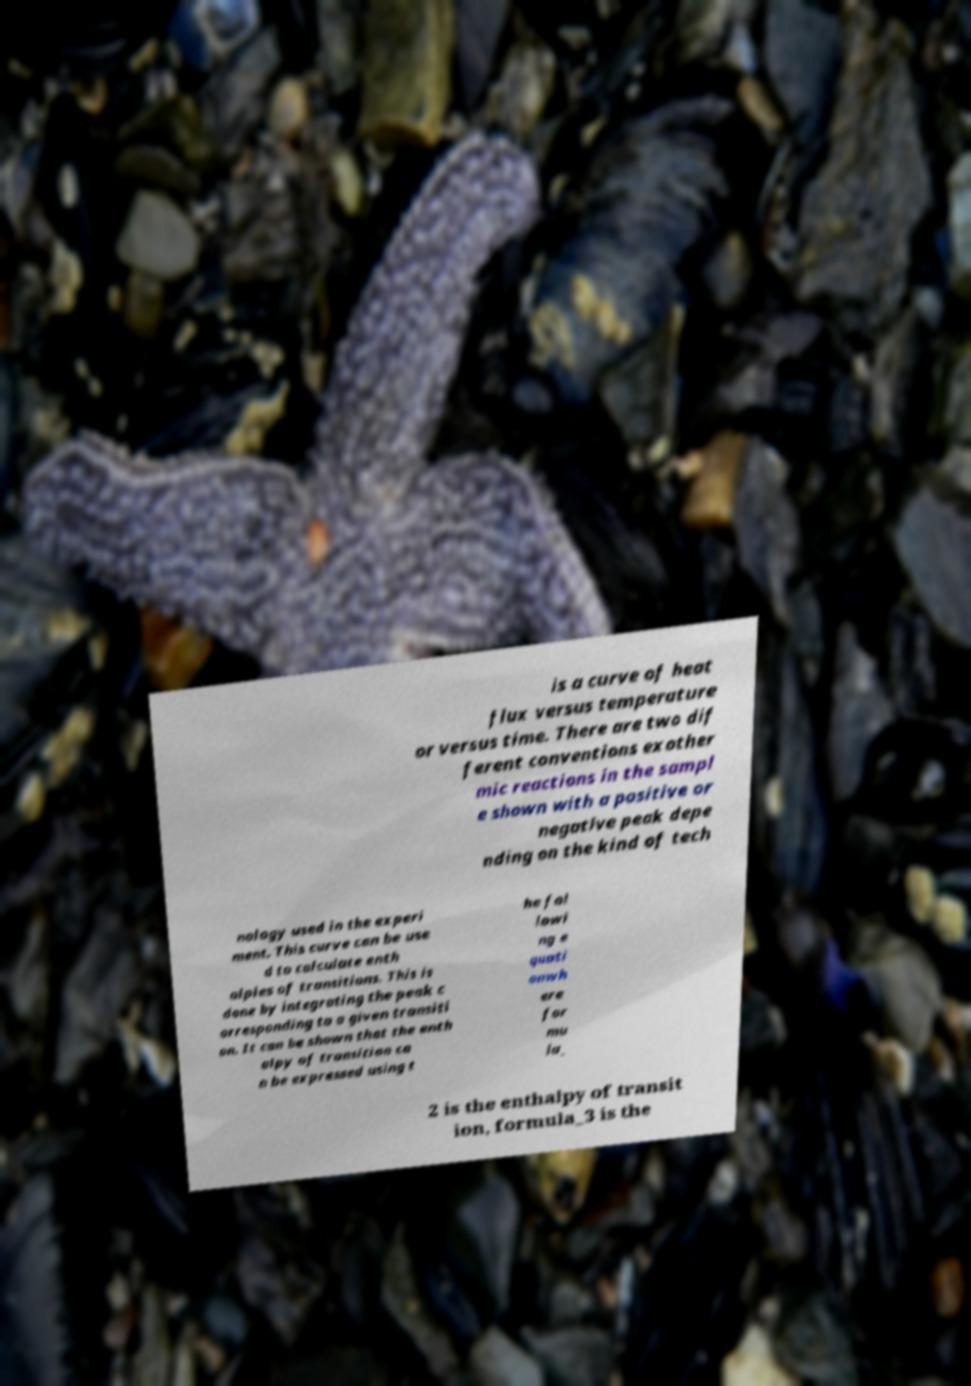Please identify and transcribe the text found in this image. is a curve of heat flux versus temperature or versus time. There are two dif ferent conventions exother mic reactions in the sampl e shown with a positive or negative peak depe nding on the kind of tech nology used in the experi ment. This curve can be use d to calculate enth alpies of transitions. This is done by integrating the peak c orresponding to a given transiti on. It can be shown that the enth alpy of transition ca n be expressed using t he fol lowi ng e quati onwh ere for mu la_ 2 is the enthalpy of transit ion, formula_3 is the 